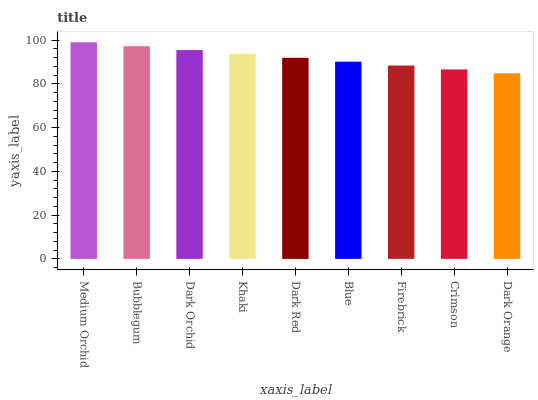Is Dark Orange the minimum?
Answer yes or no. Yes. Is Medium Orchid the maximum?
Answer yes or no. Yes. Is Bubblegum the minimum?
Answer yes or no. No. Is Bubblegum the maximum?
Answer yes or no. No. Is Medium Orchid greater than Bubblegum?
Answer yes or no. Yes. Is Bubblegum less than Medium Orchid?
Answer yes or no. Yes. Is Bubblegum greater than Medium Orchid?
Answer yes or no. No. Is Medium Orchid less than Bubblegum?
Answer yes or no. No. Is Dark Red the high median?
Answer yes or no. Yes. Is Dark Red the low median?
Answer yes or no. Yes. Is Blue the high median?
Answer yes or no. No. Is Medium Orchid the low median?
Answer yes or no. No. 